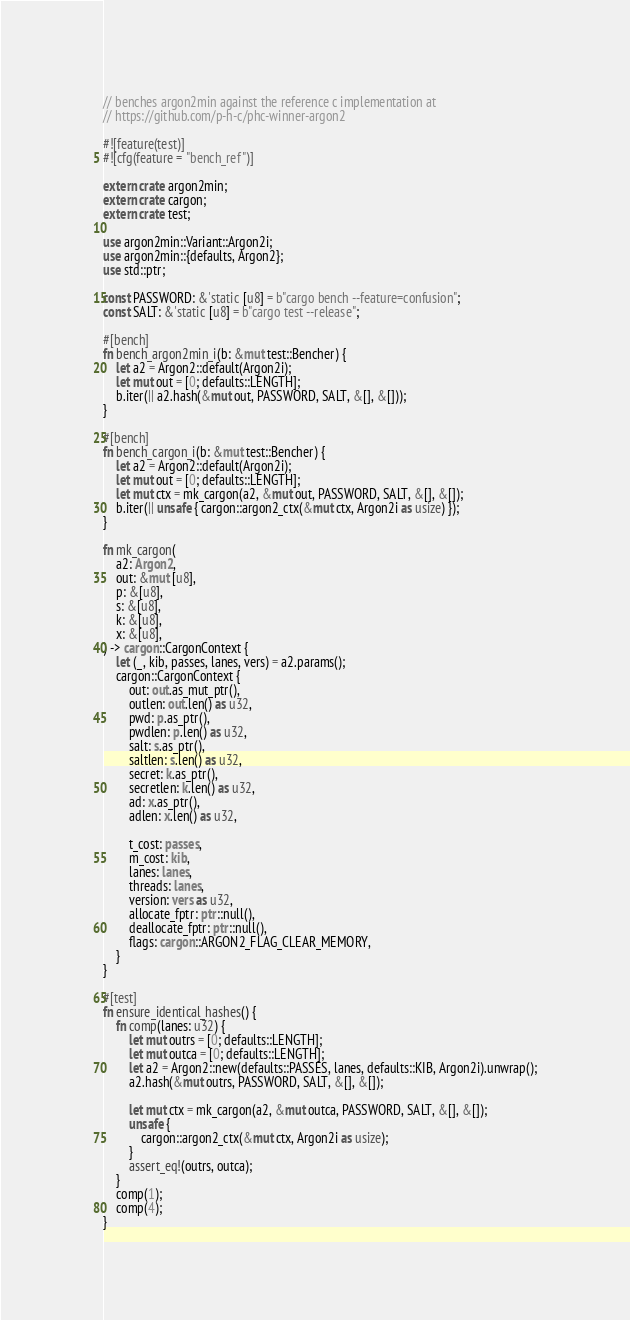Convert code to text. <code><loc_0><loc_0><loc_500><loc_500><_Rust_>// benches argon2min against the reference c implementation at
// https://github.com/p-h-c/phc-winner-argon2

#![feature(test)]
#![cfg(feature = "bench_ref")]

extern crate argon2min;
extern crate cargon;
extern crate test;

use argon2min::Variant::Argon2i;
use argon2min::{defaults, Argon2};
use std::ptr;

const PASSWORD: &'static [u8] = b"cargo bench --feature=confusion";
const SALT: &'static [u8] = b"cargo test --release";

#[bench]
fn bench_argon2min_i(b: &mut test::Bencher) {
    let a2 = Argon2::default(Argon2i);
    let mut out = [0; defaults::LENGTH];
    b.iter(|| a2.hash(&mut out, PASSWORD, SALT, &[], &[]));
}

#[bench]
fn bench_cargon_i(b: &mut test::Bencher) {
    let a2 = Argon2::default(Argon2i);
    let mut out = [0; defaults::LENGTH];
    let mut ctx = mk_cargon(a2, &mut out, PASSWORD, SALT, &[], &[]);
    b.iter(|| unsafe { cargon::argon2_ctx(&mut ctx, Argon2i as usize) });
}

fn mk_cargon(
    a2: Argon2,
    out: &mut [u8],
    p: &[u8],
    s: &[u8],
    k: &[u8],
    x: &[u8],
) -> cargon::CargonContext {
    let (_, kib, passes, lanes, vers) = a2.params();
    cargon::CargonContext {
        out: out.as_mut_ptr(),
        outlen: out.len() as u32,
        pwd: p.as_ptr(),
        pwdlen: p.len() as u32,
        salt: s.as_ptr(),
        saltlen: s.len() as u32,
        secret: k.as_ptr(),
        secretlen: k.len() as u32,
        ad: x.as_ptr(),
        adlen: x.len() as u32,

        t_cost: passes,
        m_cost: kib,
        lanes: lanes,
        threads: lanes,
        version: vers as u32,
        allocate_fptr: ptr::null(),
        deallocate_fptr: ptr::null(),
        flags: cargon::ARGON2_FLAG_CLEAR_MEMORY,
    }
}

#[test]
fn ensure_identical_hashes() {
    fn comp(lanes: u32) {
        let mut outrs = [0; defaults::LENGTH];
        let mut outca = [0; defaults::LENGTH];
        let a2 = Argon2::new(defaults::PASSES, lanes, defaults::KIB, Argon2i).unwrap();
        a2.hash(&mut outrs, PASSWORD, SALT, &[], &[]);

        let mut ctx = mk_cargon(a2, &mut outca, PASSWORD, SALT, &[], &[]);
        unsafe {
            cargon::argon2_ctx(&mut ctx, Argon2i as usize);
        }
        assert_eq!(outrs, outca);
    }
    comp(1);
    comp(4);
}
</code> 